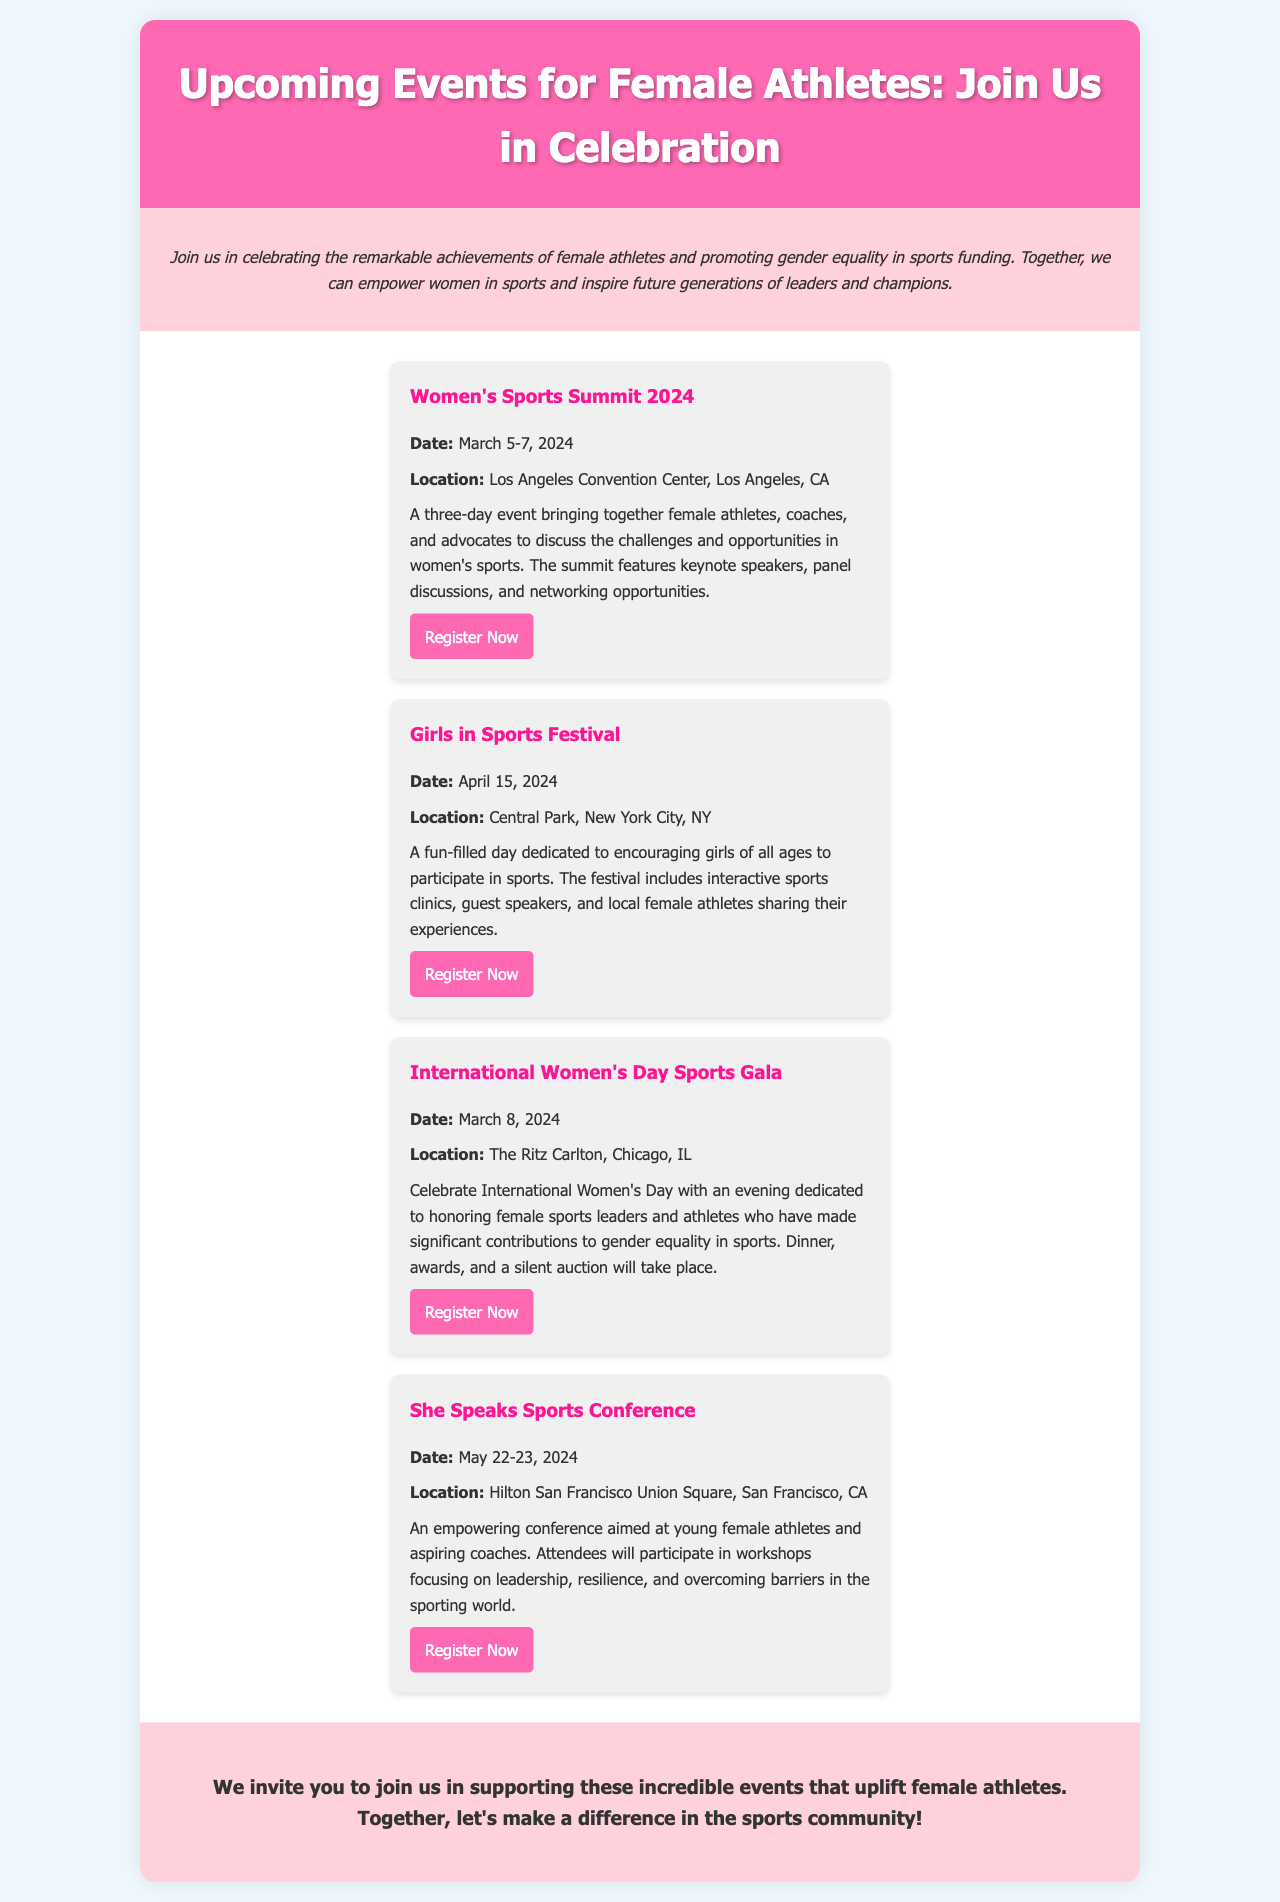What is the name of the first event? The first event listed is titled "Women's Sports Summit 2024."
Answer: Women's Sports Summit 2024 When is the Girls in Sports Festival scheduled? The document states that the Girls in Sports Festival is on April 15, 2024.
Answer: April 15, 2024 What is the location of the International Women's Day Sports Gala? The event is located at The Ritz Carlton, Chicago, IL.
Answer: The Ritz Carlton, Chicago, IL How many days does the Women's Sports Summit span? The summit occurs over three days, from March 5 to March 7, 2024.
Answer: Three days What is the main theme of the "She Speaks Sports Conference"? The conference focuses on leadership, resilience, and overcoming barriers in sports.
Answer: Leadership, resilience, and overcoming barriers Who is the target audience for the Girls in Sports Festival? The festival aims to encourage girls of all ages to participate in sports.
Answer: Girls of all ages What type of event is the International Women's Day Sports Gala? It is a gala to honor female sports leaders and athletes.
Answer: Gala What is the purpose of the brochure? The brochure aims to promote upcoming events for female athletes and celebrate their achievements.
Answer: Promote upcoming events for female athletes 